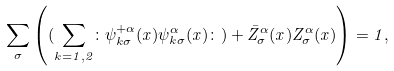Convert formula to latex. <formula><loc_0><loc_0><loc_500><loc_500>\sum _ { \sigma } \left ( ( \sum _ { k = 1 , 2 } \colon \psi ^ { + \alpha } _ { k \sigma } ( x ) \psi ^ { \alpha } _ { k \sigma } ( x ) \colon ) + \bar { Z } ^ { \alpha } _ { \sigma } ( x ) Z ^ { \alpha } _ { \sigma } ( x ) \right ) = 1 ,</formula> 